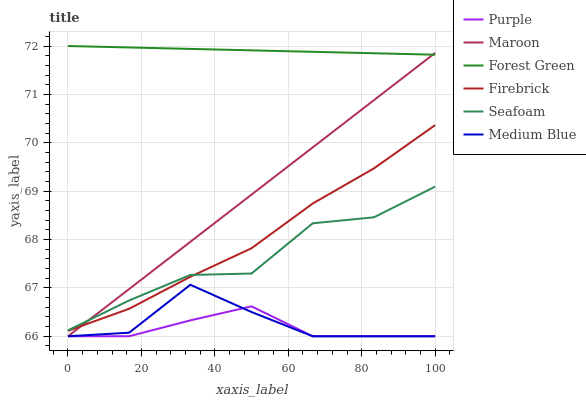Does Firebrick have the minimum area under the curve?
Answer yes or no. No. Does Firebrick have the maximum area under the curve?
Answer yes or no. No. Is Firebrick the smoothest?
Answer yes or no. No. Is Firebrick the roughest?
Answer yes or no. No. Does Firebrick have the lowest value?
Answer yes or no. No. Does Firebrick have the highest value?
Answer yes or no. No. Is Purple less than Seafoam?
Answer yes or no. Yes. Is Firebrick greater than Purple?
Answer yes or no. Yes. Does Purple intersect Seafoam?
Answer yes or no. No. 